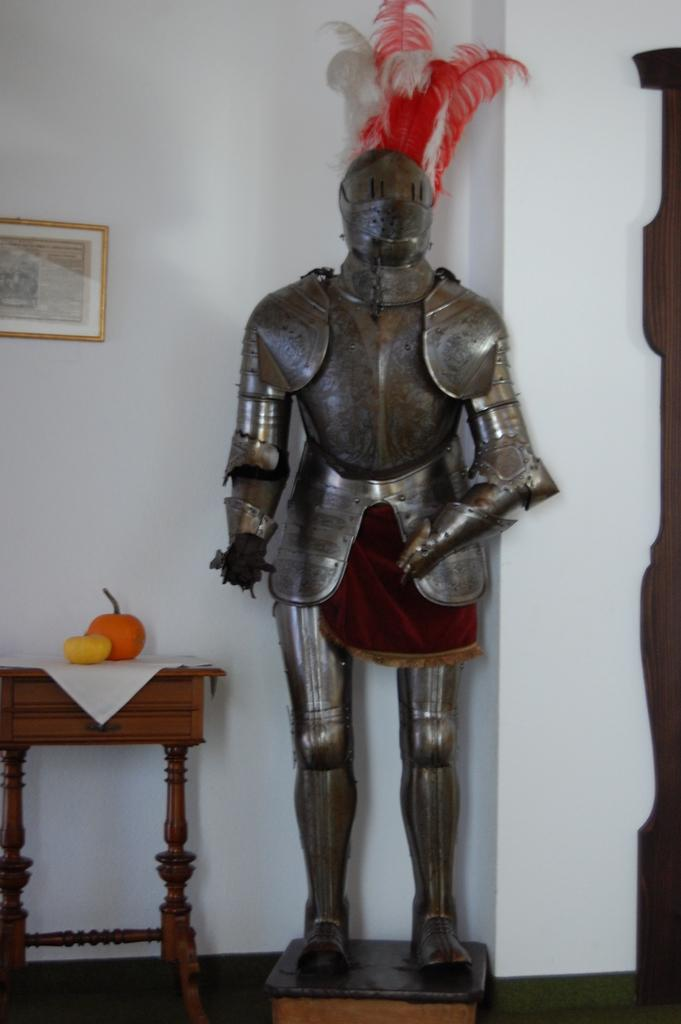What is the main subject of the image? There is a statue with feathers in the image. What else can be seen on the table in the image? There are fruits on the table in the image. Where is the picture frame located in the image? The picture frame is on the left side of the image. Is the statue crying in the image? There is no indication in the image that the statue is crying; it is a statue with feathers. What type of ball is present in the image? There is no ball present in the image. 